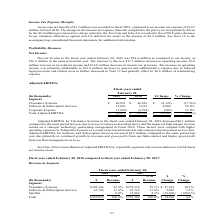According to Calamp's financial document, What was the Total Adjusted EBITDA for the fiscal year ended February 28, 2018? According to the financial document, 52,382 (in thousands). The relevant text states: "794) (905) 19.0% Total Adjusted EBITDA $ 48,215 $ 52,382 $ (4,167) (8.0%)..." Also, What were other factors that caused the decrease in adjusted EBITDA for Telematics Systems other than lower revenues and impact of high margin revenue earned? increased headcount and outsourced professional service fees.. The document states: "ting expenses in Telematics Systems as a result of increased headcount and outsourced professional service fees. Adjusted EBITDA for Software and Subs..." Also, What was the Total Adjusted EBITDA for the fiscal year ended February 28, 2019? According to the financial document, 48,215 (in thousands). The relevant text states: ",699) (4,794) (905) 19.0% Total Adjusted EBITDA $ 48,215 $ 52,382 $ (4,167) (8.0%)..." Also, can you calculate: What is the total Adjusted EBITDA for Telematics Systems and Software & Subscription Services in 2019?  Based on the calculation: (40,821+13,093), the result is 53914 (in thousands). This is based on the information: "(8,122) (17.0%) Software & Subscription Services 13,093 8,233 4,860 59.0% Corporate Expense (5,699) (4,794) (905) 19.0% Total Adjusted EBITDA $ 48,215 $ 52 18 $ Change % Change Segment Telematics Syst..." The key data points involved are: 13,093, 40,821. Also, can you calculate: What is the total Adjusted EBITDA for Telematics Systems and Software & Subscription Services in 2018? Based on the calculation: (48,943+8,233), the result is 57176 (in thousands). This is based on the information: "ge % Change Segment Telematics Systems $ 40,821 $ 48,943 $ (8,122) (17.0%) Software & Subscription Services 13,093 8,233 4,860 59.0% Corporate Expense (5,69 ) (17.0%) Software & Subscription Services ..." The key data points involved are: 48,943, 8,233. Also, can you calculate: What was the average Corporate Expense for both years, 2018 and 2019? To answer this question, I need to perform calculations using the financial data. The calculation is: (-5,699-4,794)/(2019-2018+1), which equals -5246.5 (in thousands). This is based on the information: ",093 8,233 4,860 59.0% Corporate Expense (5,699) (4,794) (905) 19.0% Total Adjusted EBITDA $ 48,215 $ 52,382 $ (4,167) (8.0%) vices 13,093 8,233 4,860 59.0% Corporate Expense (5,699) (4,794) (905) 19...." The key data points involved are: 4,794, 5,699. 